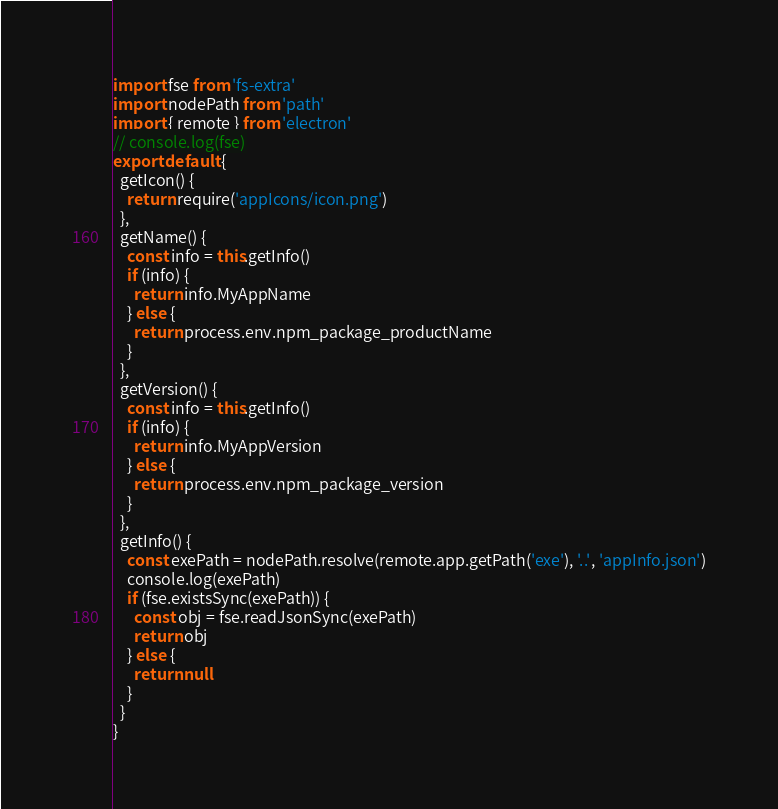<code> <loc_0><loc_0><loc_500><loc_500><_JavaScript_>import fse from 'fs-extra'
import nodePath from 'path'
import { remote } from 'electron'
// console.log(fse)
export default {
  getIcon() {
    return require('appIcons/icon.png')
  },
  getName() {
    const info = this.getInfo()
    if (info) {
      return info.MyAppName
    } else {
      return process.env.npm_package_productName
    }
  },
  getVersion() {
    const info = this.getInfo()
    if (info) {
      return info.MyAppVersion
    } else {
      return process.env.npm_package_version
    }
  },
  getInfo() {
    const exePath = nodePath.resolve(remote.app.getPath('exe'), '..', 'appInfo.json')
    console.log(exePath)
    if (fse.existsSync(exePath)) {
      const obj = fse.readJsonSync(exePath)
      return obj
    } else {
      return null
    }
  }
}
</code> 